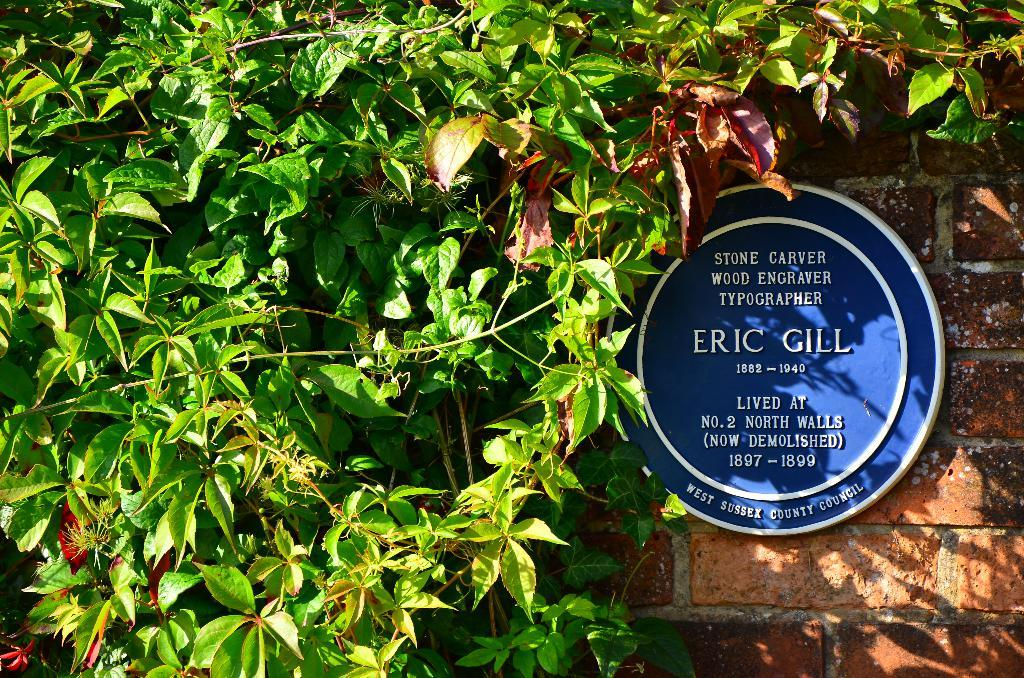What is on the board that is visible in the image? There is text on the board in the image. Where is the board located in the image? The board is placed on a wall in the image. What can be seen in the background of the image? Leaves are visible in the background of the image. What type of print can be seen on the bears' clothing in the image? There are no bears or clothing present in the image; it features a board with text on a wall and leaves in the background. 